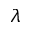<formula> <loc_0><loc_0><loc_500><loc_500>\lambda</formula> 